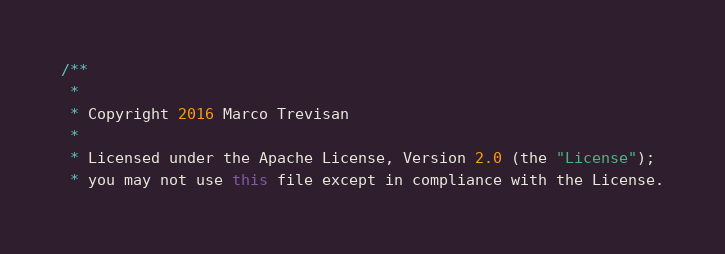Convert code to text. <code><loc_0><loc_0><loc_500><loc_500><_Java_>/**
 *
 * Copyright 2016 Marco Trevisan
 *
 * Licensed under the Apache License, Version 2.0 (the "License");
 * you may not use this file except in compliance with the License.</code> 